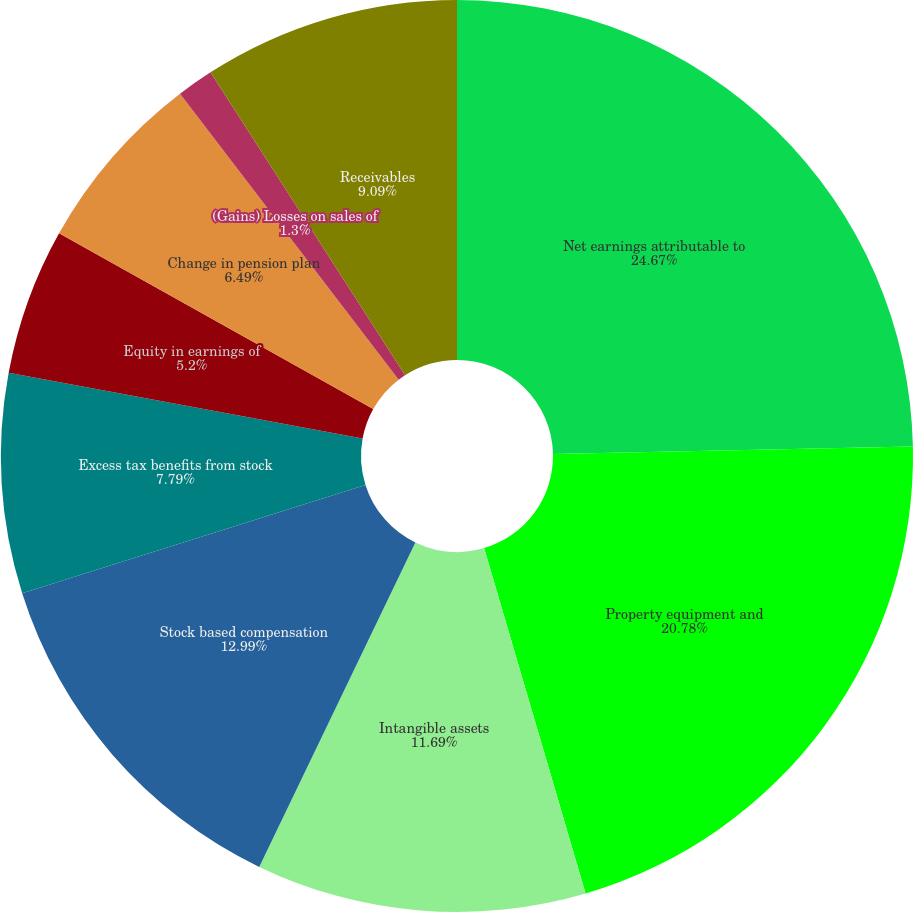Convert chart. <chart><loc_0><loc_0><loc_500><loc_500><pie_chart><fcel>Net earnings attributable to<fcel>Property equipment and<fcel>Intangible assets<fcel>Stock based compensation<fcel>Excess tax benefits from stock<fcel>Equity in earnings of<fcel>Change in pension plan<fcel>(Gains) Losses on sales of<fcel>Receivables<fcel>Prepaid expenses and other<nl><fcel>24.67%<fcel>20.78%<fcel>11.69%<fcel>12.99%<fcel>7.79%<fcel>5.2%<fcel>6.49%<fcel>1.3%<fcel>9.09%<fcel>0.0%<nl></chart> 